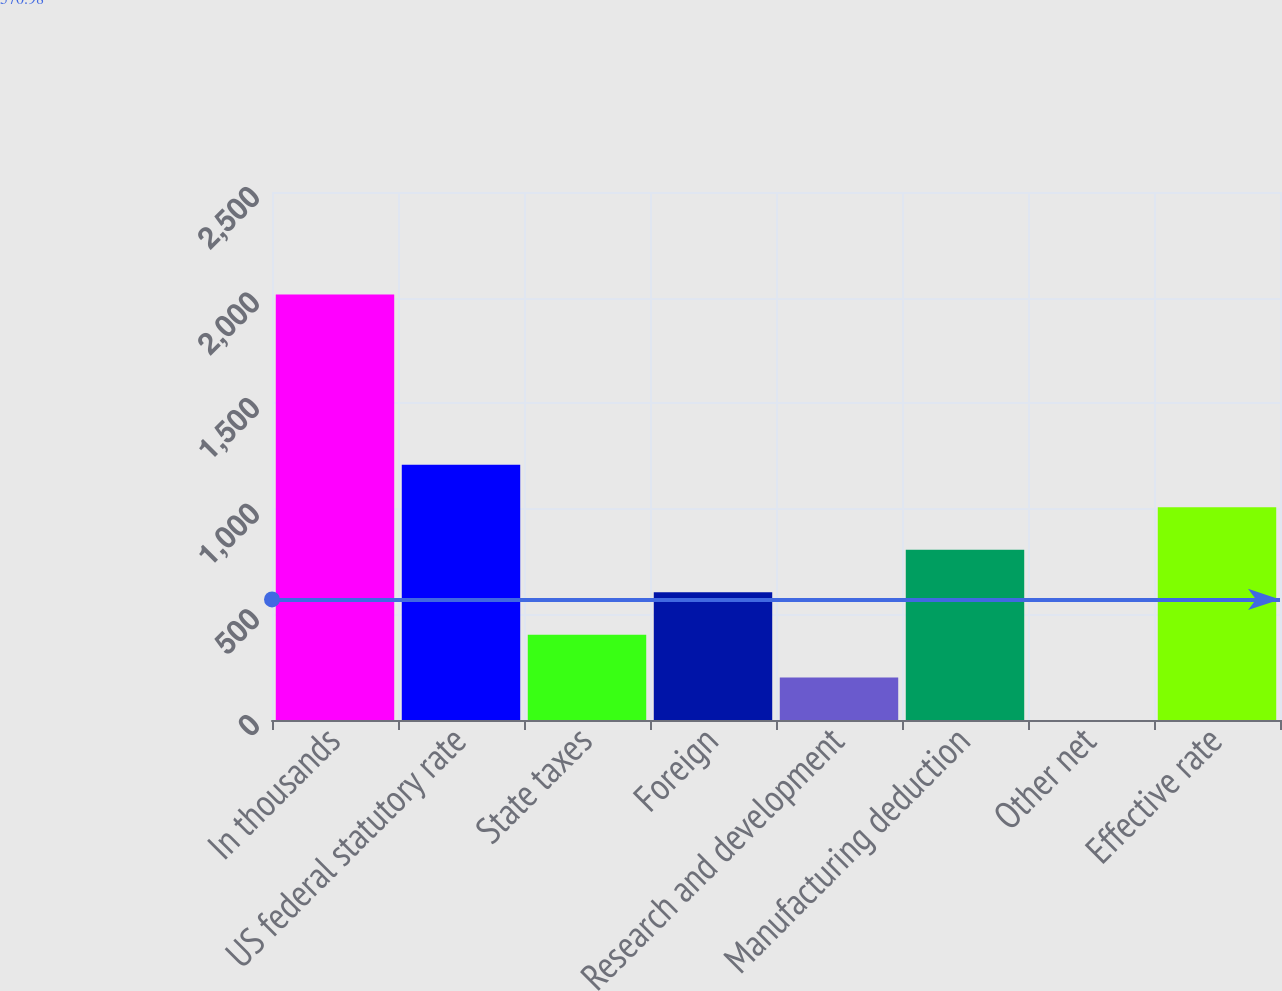Convert chart to OTSL. <chart><loc_0><loc_0><loc_500><loc_500><bar_chart><fcel>In thousands<fcel>US federal statutory rate<fcel>State taxes<fcel>Foreign<fcel>Research and development<fcel>Manufacturing deduction<fcel>Other net<fcel>Effective rate<nl><fcel>2015<fcel>1209.04<fcel>403.08<fcel>604.57<fcel>201.59<fcel>806.06<fcel>0.1<fcel>1007.55<nl></chart> 